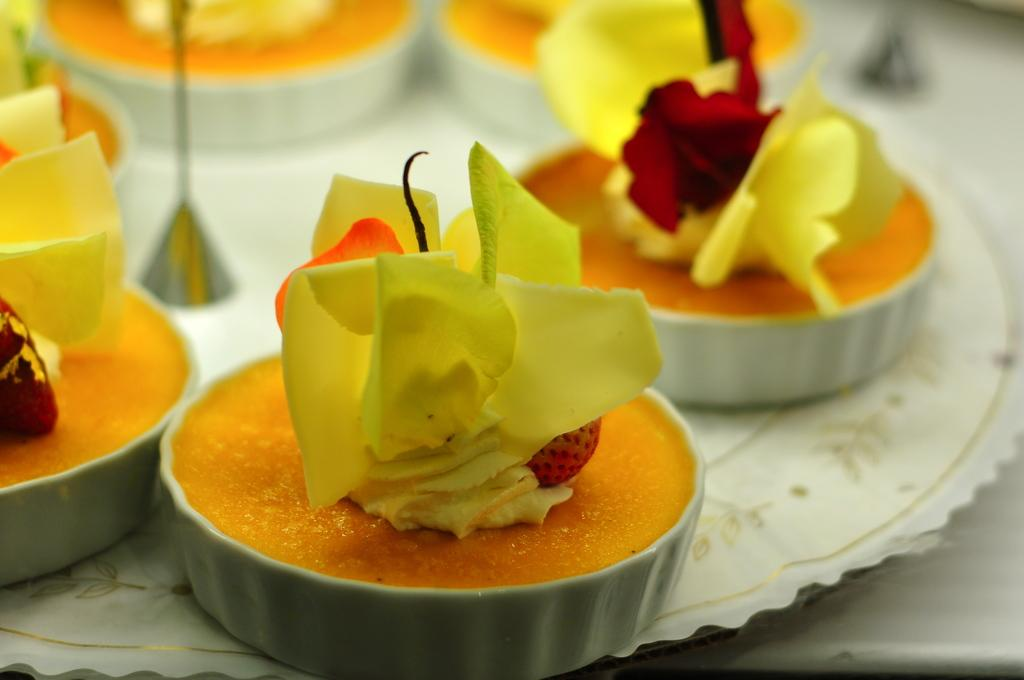What type of food can be seen in the image? There are desserts in the image. How are the desserts arranged in the image? The desserts are in a plate. Where is the plate with desserts located? The plate is placed on a table. What type of lamp can be seen in the image? There is no lamp present in the image. How many pears are visible in the image? There are no pears present in the image. 